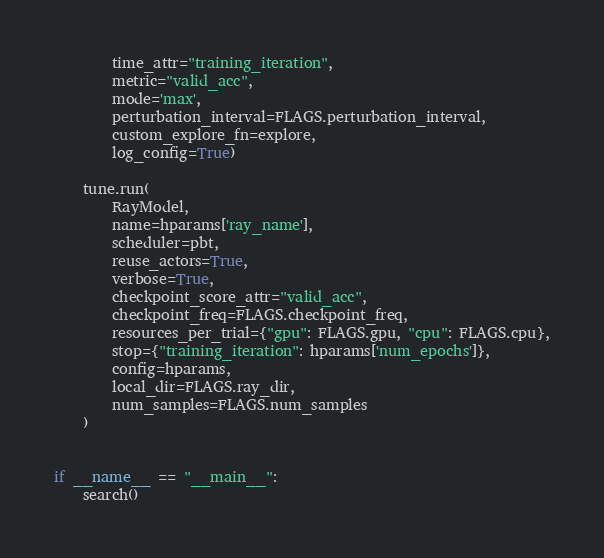<code> <loc_0><loc_0><loc_500><loc_500><_Python_>        time_attr="training_iteration",
        metric="valid_acc",
        mode='max',
        perturbation_interval=FLAGS.perturbation_interval,
        custom_explore_fn=explore,
        log_config=True)

    tune.run(
        RayModel,
        name=hparams['ray_name'],
        scheduler=pbt,
        reuse_actors=True,
        verbose=True,
        checkpoint_score_attr="valid_acc",
        checkpoint_freq=FLAGS.checkpoint_freq,
        resources_per_trial={"gpu": FLAGS.gpu, "cpu": FLAGS.cpu},
        stop={"training_iteration": hparams['num_epochs']},
        config=hparams,
        local_dir=FLAGS.ray_dir,
        num_samples=FLAGS.num_samples
    )


if __name__ == "__main__":
    search()
</code> 